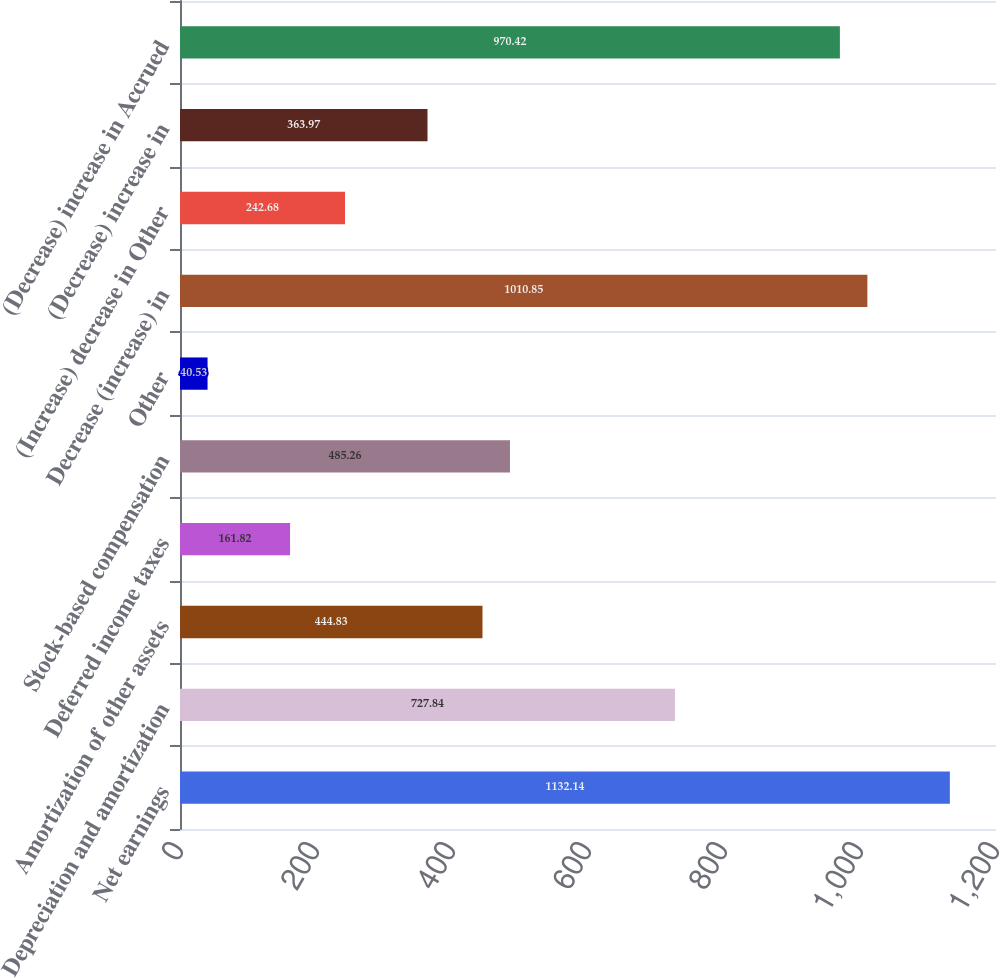Convert chart. <chart><loc_0><loc_0><loc_500><loc_500><bar_chart><fcel>Net earnings<fcel>Depreciation and amortization<fcel>Amortization of other assets<fcel>Deferred income taxes<fcel>Stock-based compensation<fcel>Other<fcel>Decrease (increase) in<fcel>(Increase) decrease in Other<fcel>(Decrease) increase in<fcel>(Decrease) increase in Accrued<nl><fcel>1132.14<fcel>727.84<fcel>444.83<fcel>161.82<fcel>485.26<fcel>40.53<fcel>1010.85<fcel>242.68<fcel>363.97<fcel>970.42<nl></chart> 